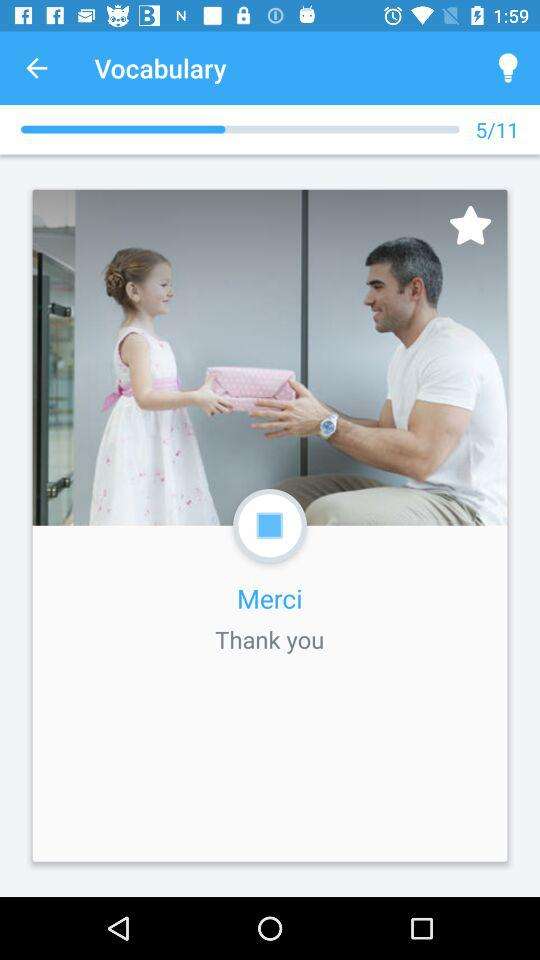What is the total number of questions in "Vocabulary"? The total number of questions is 11. 